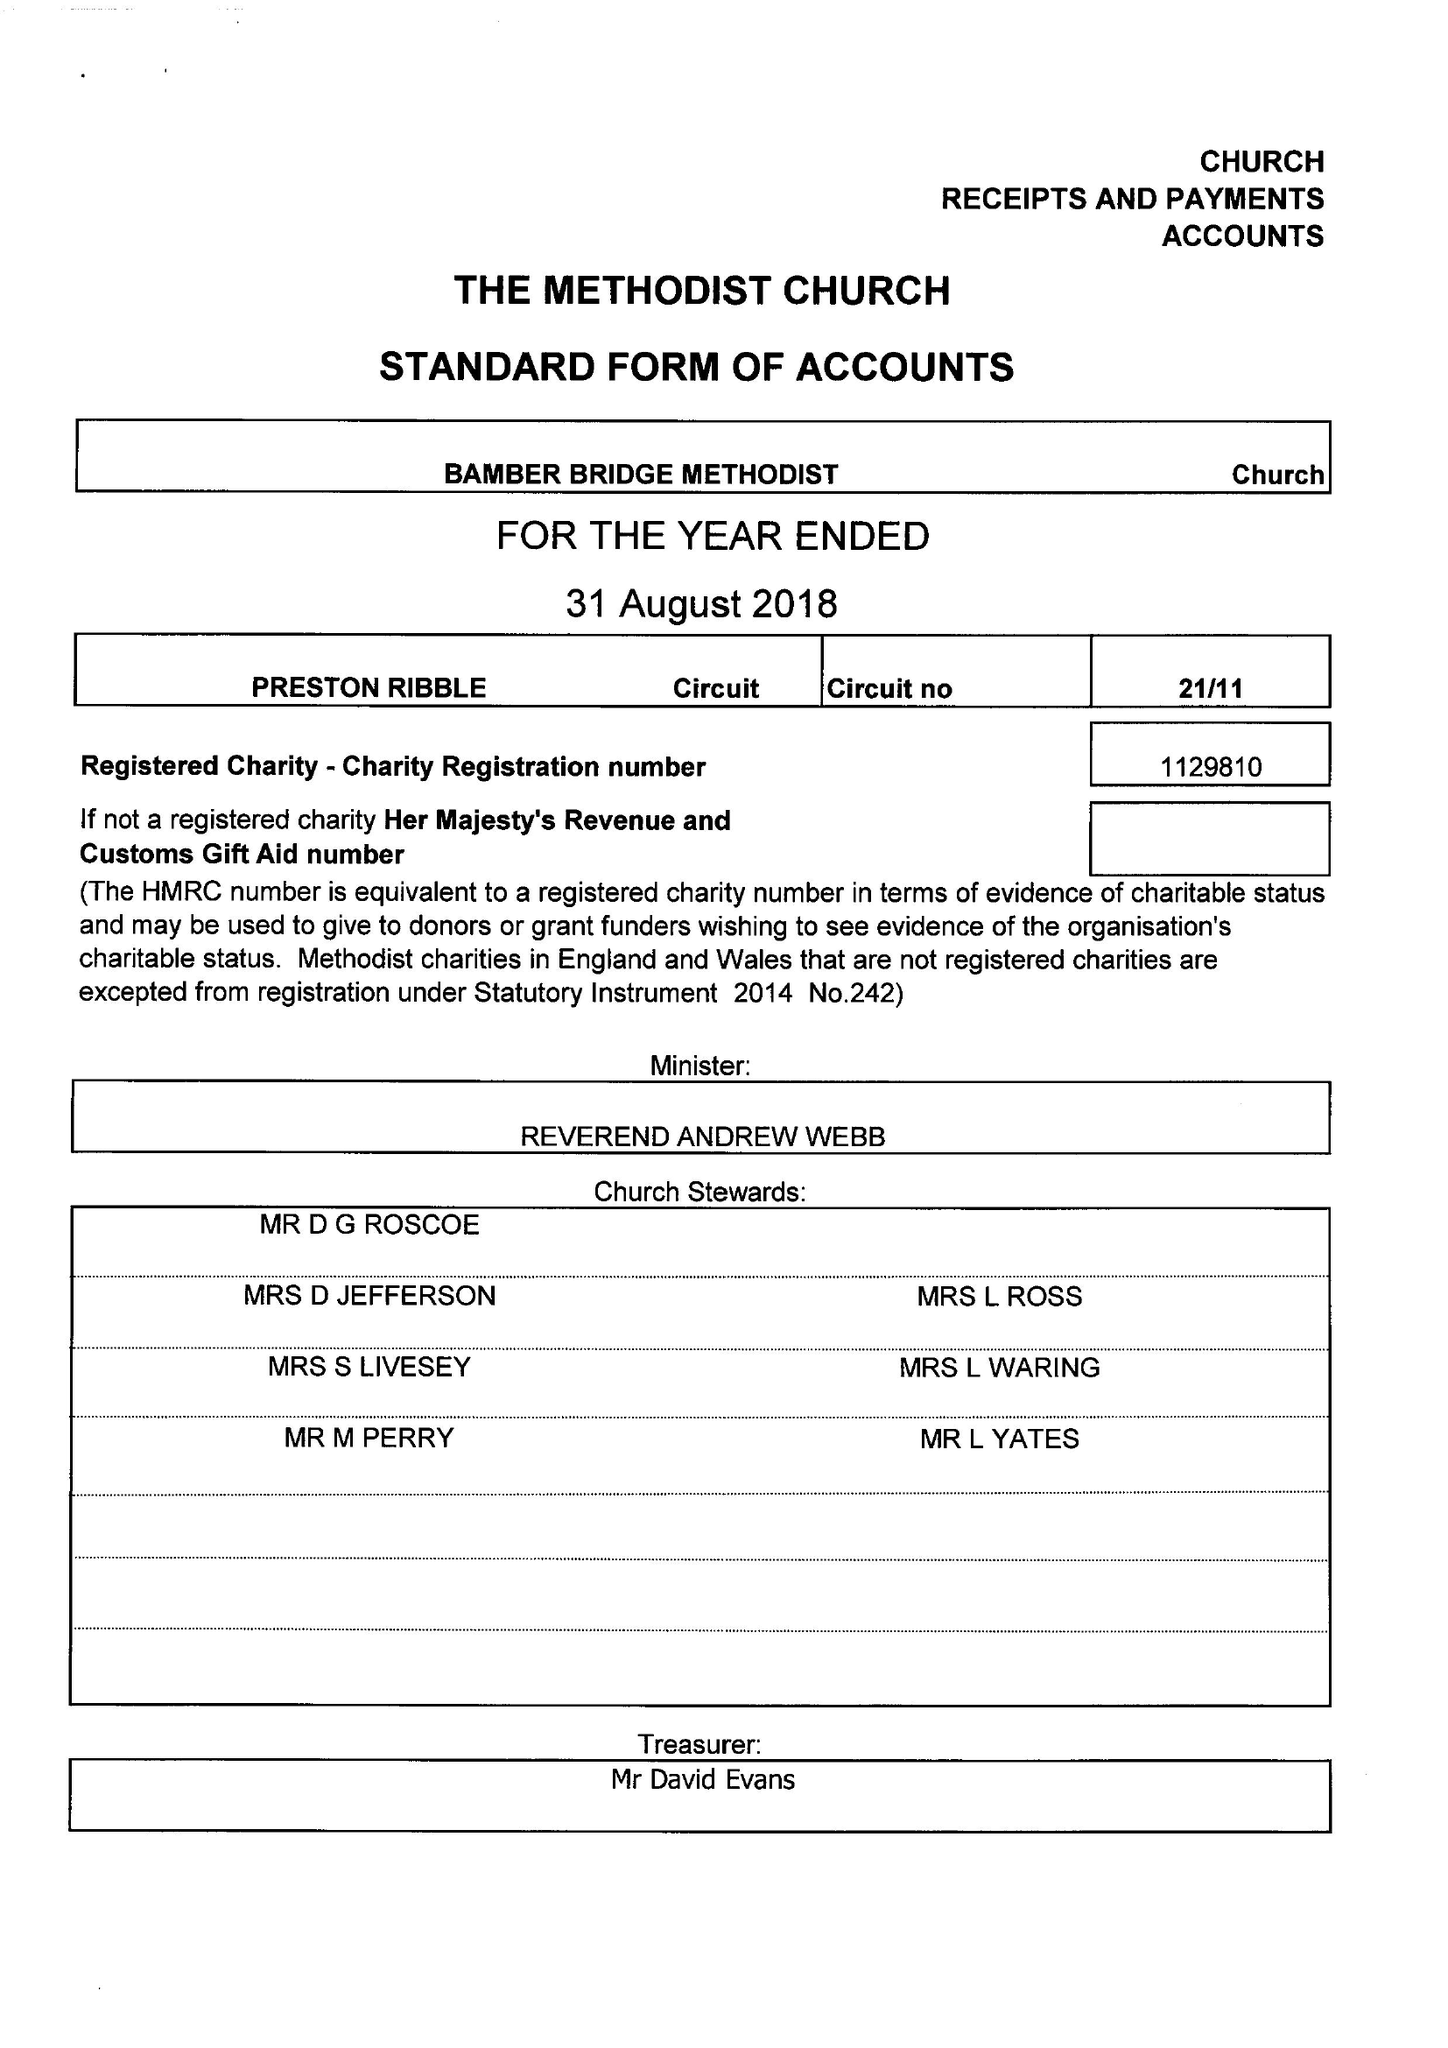What is the value for the report_date?
Answer the question using a single word or phrase. 2018-08-31 